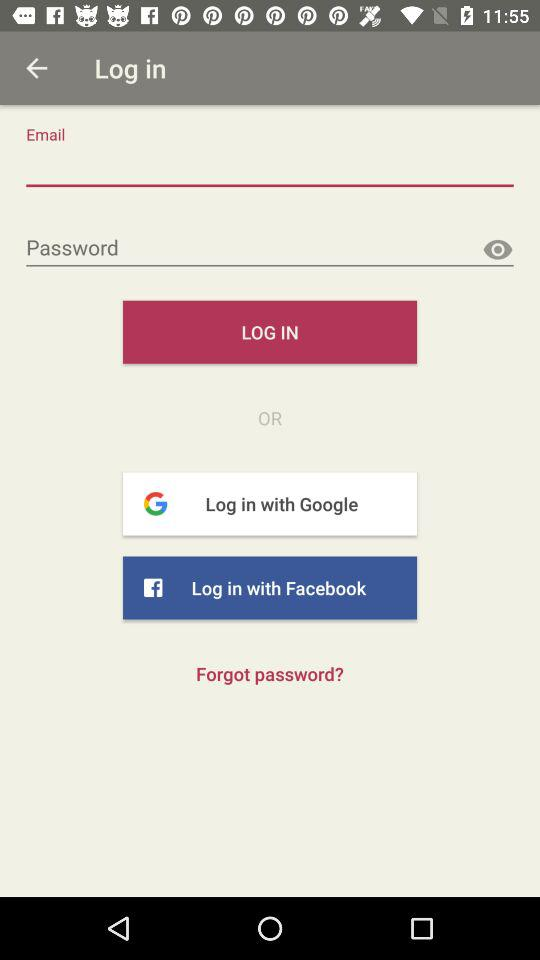How many login options are there?
Answer the question using a single word or phrase. 3 